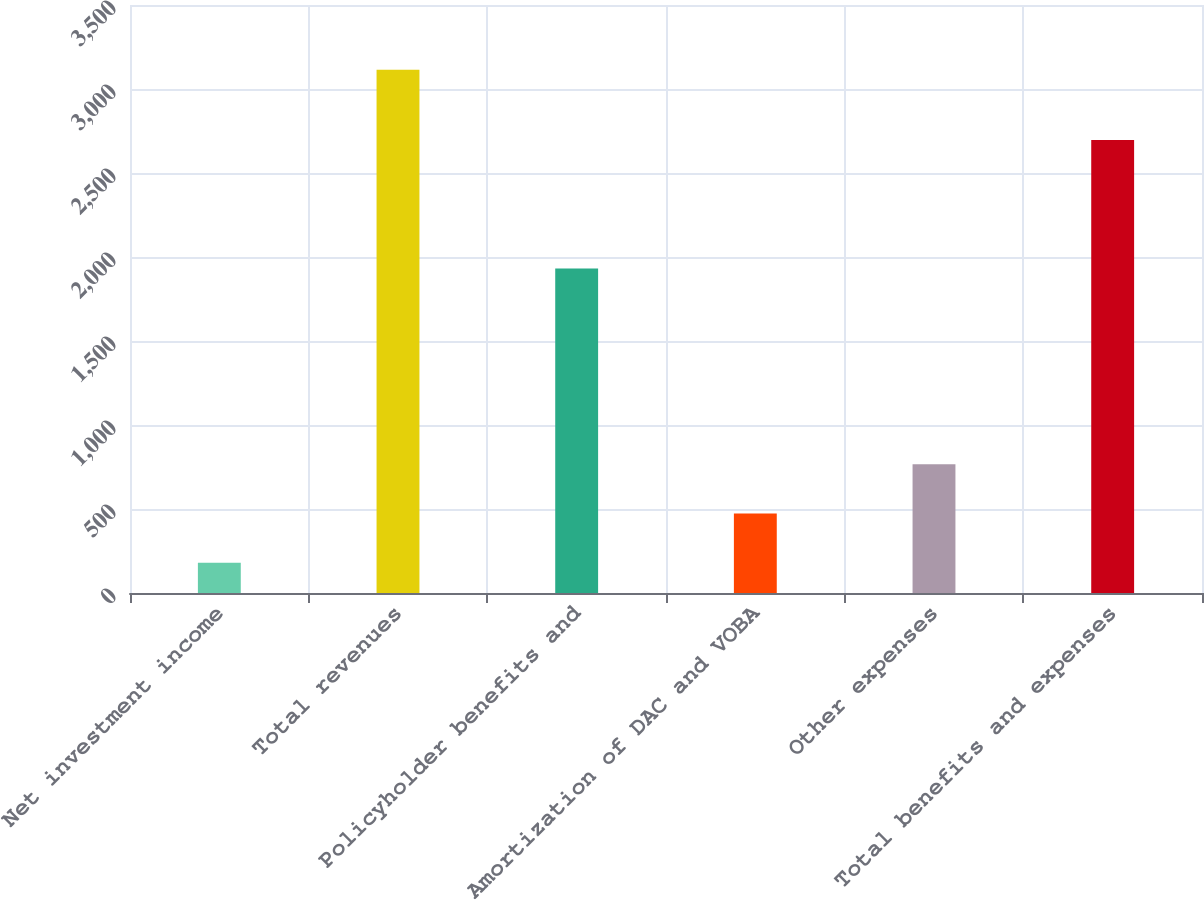Convert chart. <chart><loc_0><loc_0><loc_500><loc_500><bar_chart><fcel>Net investment income<fcel>Total revenues<fcel>Policyholder benefits and<fcel>Amortization of DAC and VOBA<fcel>Other expenses<fcel>Total benefits and expenses<nl><fcel>180<fcel>3115<fcel>1932<fcel>473.5<fcel>767<fcel>2697<nl></chart> 